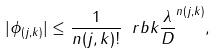<formula> <loc_0><loc_0><loc_500><loc_500>| \phi _ { ( j , k ) } | \leq \frac { 1 } { n ( j , k ) ! } \ r b k { \frac { \lambda } { D } } ^ { n ( j , k ) } ,</formula> 